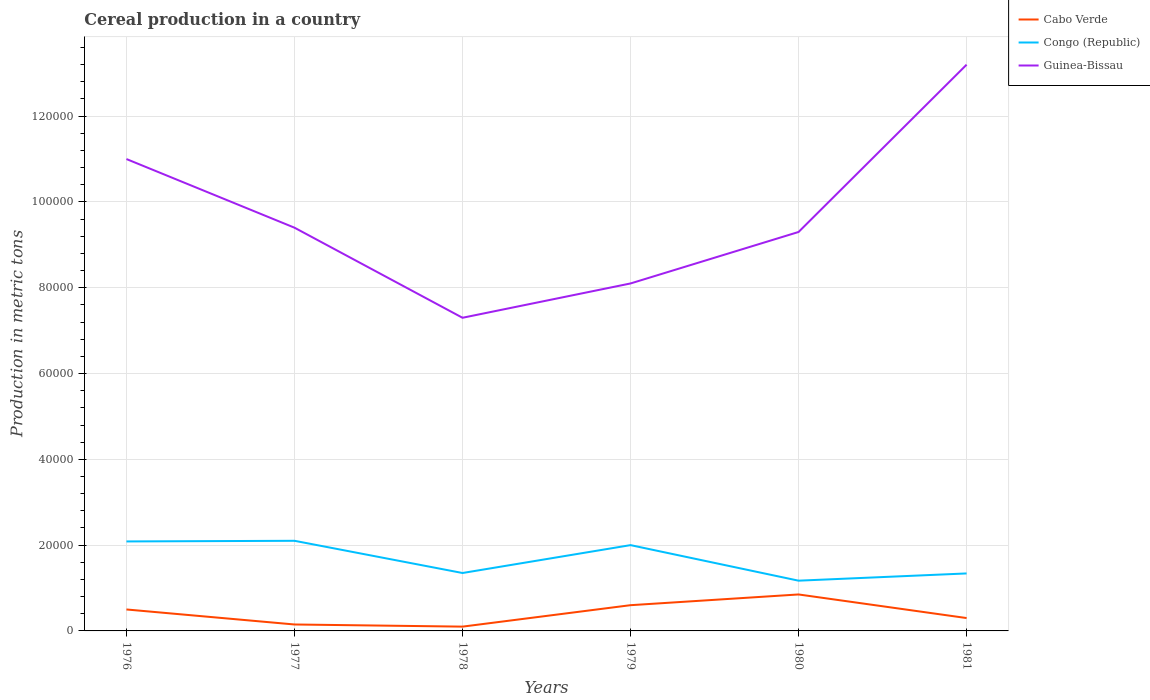How many different coloured lines are there?
Make the answer very short. 3. Across all years, what is the maximum total cereal production in Congo (Republic)?
Keep it short and to the point. 1.17e+04. In which year was the total cereal production in Cabo Verde maximum?
Your response must be concise. 1978. What is the total total cereal production in Cabo Verde in the graph?
Make the answer very short. 3000. What is the difference between the highest and the second highest total cereal production in Congo (Republic)?
Give a very brief answer. 9298. What is the difference between the highest and the lowest total cereal production in Congo (Republic)?
Provide a short and direct response. 3. How many years are there in the graph?
Make the answer very short. 6. Does the graph contain any zero values?
Provide a succinct answer. No. Does the graph contain grids?
Offer a terse response. Yes. What is the title of the graph?
Ensure brevity in your answer.  Cereal production in a country. What is the label or title of the Y-axis?
Ensure brevity in your answer.  Production in metric tons. What is the Production in metric tons in Congo (Republic) in 1976?
Ensure brevity in your answer.  2.09e+04. What is the Production in metric tons of Cabo Verde in 1977?
Your answer should be compact. 1500. What is the Production in metric tons of Congo (Republic) in 1977?
Keep it short and to the point. 2.10e+04. What is the Production in metric tons in Guinea-Bissau in 1977?
Offer a terse response. 9.40e+04. What is the Production in metric tons in Congo (Republic) in 1978?
Your answer should be very brief. 1.35e+04. What is the Production in metric tons of Guinea-Bissau in 1978?
Ensure brevity in your answer.  7.30e+04. What is the Production in metric tons of Cabo Verde in 1979?
Your answer should be compact. 6000. What is the Production in metric tons of Congo (Republic) in 1979?
Give a very brief answer. 2.00e+04. What is the Production in metric tons of Guinea-Bissau in 1979?
Give a very brief answer. 8.10e+04. What is the Production in metric tons of Cabo Verde in 1980?
Your answer should be very brief. 8500. What is the Production in metric tons of Congo (Republic) in 1980?
Make the answer very short. 1.17e+04. What is the Production in metric tons of Guinea-Bissau in 1980?
Your answer should be very brief. 9.30e+04. What is the Production in metric tons of Cabo Verde in 1981?
Your response must be concise. 3000. What is the Production in metric tons in Congo (Republic) in 1981?
Provide a succinct answer. 1.34e+04. What is the Production in metric tons in Guinea-Bissau in 1981?
Make the answer very short. 1.32e+05. Across all years, what is the maximum Production in metric tons of Cabo Verde?
Offer a very short reply. 8500. Across all years, what is the maximum Production in metric tons of Congo (Republic)?
Give a very brief answer. 2.10e+04. Across all years, what is the maximum Production in metric tons in Guinea-Bissau?
Provide a short and direct response. 1.32e+05. Across all years, what is the minimum Production in metric tons of Congo (Republic)?
Make the answer very short. 1.17e+04. Across all years, what is the minimum Production in metric tons in Guinea-Bissau?
Provide a succinct answer. 7.30e+04. What is the total Production in metric tons of Cabo Verde in the graph?
Give a very brief answer. 2.50e+04. What is the total Production in metric tons in Congo (Republic) in the graph?
Make the answer very short. 1.00e+05. What is the total Production in metric tons in Guinea-Bissau in the graph?
Make the answer very short. 5.83e+05. What is the difference between the Production in metric tons of Cabo Verde in 1976 and that in 1977?
Ensure brevity in your answer.  3500. What is the difference between the Production in metric tons in Congo (Republic) in 1976 and that in 1977?
Your answer should be compact. -151. What is the difference between the Production in metric tons in Guinea-Bissau in 1976 and that in 1977?
Your answer should be compact. 1.60e+04. What is the difference between the Production in metric tons of Cabo Verde in 1976 and that in 1978?
Your answer should be compact. 4000. What is the difference between the Production in metric tons in Congo (Republic) in 1976 and that in 1978?
Your answer should be very brief. 7360. What is the difference between the Production in metric tons in Guinea-Bissau in 1976 and that in 1978?
Ensure brevity in your answer.  3.70e+04. What is the difference between the Production in metric tons of Cabo Verde in 1976 and that in 1979?
Your answer should be very brief. -1000. What is the difference between the Production in metric tons in Congo (Republic) in 1976 and that in 1979?
Your answer should be very brief. 860. What is the difference between the Production in metric tons of Guinea-Bissau in 1976 and that in 1979?
Offer a very short reply. 2.90e+04. What is the difference between the Production in metric tons of Cabo Verde in 1976 and that in 1980?
Provide a short and direct response. -3500. What is the difference between the Production in metric tons of Congo (Republic) in 1976 and that in 1980?
Keep it short and to the point. 9147. What is the difference between the Production in metric tons of Guinea-Bissau in 1976 and that in 1980?
Ensure brevity in your answer.  1.70e+04. What is the difference between the Production in metric tons of Congo (Republic) in 1976 and that in 1981?
Your answer should be very brief. 7460. What is the difference between the Production in metric tons in Guinea-Bissau in 1976 and that in 1981?
Keep it short and to the point. -2.20e+04. What is the difference between the Production in metric tons in Cabo Verde in 1977 and that in 1978?
Provide a succinct answer. 500. What is the difference between the Production in metric tons in Congo (Republic) in 1977 and that in 1978?
Your response must be concise. 7511. What is the difference between the Production in metric tons in Guinea-Bissau in 1977 and that in 1978?
Your answer should be compact. 2.10e+04. What is the difference between the Production in metric tons in Cabo Verde in 1977 and that in 1979?
Your answer should be very brief. -4500. What is the difference between the Production in metric tons in Congo (Republic) in 1977 and that in 1979?
Offer a terse response. 1011. What is the difference between the Production in metric tons in Guinea-Bissau in 1977 and that in 1979?
Provide a succinct answer. 1.30e+04. What is the difference between the Production in metric tons of Cabo Verde in 1977 and that in 1980?
Give a very brief answer. -7000. What is the difference between the Production in metric tons of Congo (Republic) in 1977 and that in 1980?
Keep it short and to the point. 9298. What is the difference between the Production in metric tons of Cabo Verde in 1977 and that in 1981?
Your answer should be very brief. -1500. What is the difference between the Production in metric tons in Congo (Republic) in 1977 and that in 1981?
Your answer should be very brief. 7611. What is the difference between the Production in metric tons in Guinea-Bissau in 1977 and that in 1981?
Your answer should be very brief. -3.80e+04. What is the difference between the Production in metric tons of Cabo Verde in 1978 and that in 1979?
Your response must be concise. -5000. What is the difference between the Production in metric tons of Congo (Republic) in 1978 and that in 1979?
Provide a short and direct response. -6500. What is the difference between the Production in metric tons of Guinea-Bissau in 1978 and that in 1979?
Provide a short and direct response. -8000. What is the difference between the Production in metric tons in Cabo Verde in 1978 and that in 1980?
Keep it short and to the point. -7500. What is the difference between the Production in metric tons of Congo (Republic) in 1978 and that in 1980?
Ensure brevity in your answer.  1787. What is the difference between the Production in metric tons of Cabo Verde in 1978 and that in 1981?
Give a very brief answer. -2000. What is the difference between the Production in metric tons of Guinea-Bissau in 1978 and that in 1981?
Keep it short and to the point. -5.90e+04. What is the difference between the Production in metric tons in Cabo Verde in 1979 and that in 1980?
Your response must be concise. -2500. What is the difference between the Production in metric tons of Congo (Republic) in 1979 and that in 1980?
Give a very brief answer. 8287. What is the difference between the Production in metric tons of Guinea-Bissau in 1979 and that in 1980?
Your response must be concise. -1.20e+04. What is the difference between the Production in metric tons of Cabo Verde in 1979 and that in 1981?
Give a very brief answer. 3000. What is the difference between the Production in metric tons of Congo (Republic) in 1979 and that in 1981?
Give a very brief answer. 6600. What is the difference between the Production in metric tons in Guinea-Bissau in 1979 and that in 1981?
Ensure brevity in your answer.  -5.10e+04. What is the difference between the Production in metric tons of Cabo Verde in 1980 and that in 1981?
Your answer should be very brief. 5500. What is the difference between the Production in metric tons in Congo (Republic) in 1980 and that in 1981?
Provide a succinct answer. -1687. What is the difference between the Production in metric tons in Guinea-Bissau in 1980 and that in 1981?
Keep it short and to the point. -3.90e+04. What is the difference between the Production in metric tons of Cabo Verde in 1976 and the Production in metric tons of Congo (Republic) in 1977?
Your response must be concise. -1.60e+04. What is the difference between the Production in metric tons of Cabo Verde in 1976 and the Production in metric tons of Guinea-Bissau in 1977?
Keep it short and to the point. -8.90e+04. What is the difference between the Production in metric tons of Congo (Republic) in 1976 and the Production in metric tons of Guinea-Bissau in 1977?
Keep it short and to the point. -7.31e+04. What is the difference between the Production in metric tons of Cabo Verde in 1976 and the Production in metric tons of Congo (Republic) in 1978?
Offer a very short reply. -8500. What is the difference between the Production in metric tons of Cabo Verde in 1976 and the Production in metric tons of Guinea-Bissau in 1978?
Keep it short and to the point. -6.80e+04. What is the difference between the Production in metric tons of Congo (Republic) in 1976 and the Production in metric tons of Guinea-Bissau in 1978?
Ensure brevity in your answer.  -5.21e+04. What is the difference between the Production in metric tons in Cabo Verde in 1976 and the Production in metric tons in Congo (Republic) in 1979?
Provide a short and direct response. -1.50e+04. What is the difference between the Production in metric tons of Cabo Verde in 1976 and the Production in metric tons of Guinea-Bissau in 1979?
Offer a very short reply. -7.60e+04. What is the difference between the Production in metric tons in Congo (Republic) in 1976 and the Production in metric tons in Guinea-Bissau in 1979?
Ensure brevity in your answer.  -6.01e+04. What is the difference between the Production in metric tons of Cabo Verde in 1976 and the Production in metric tons of Congo (Republic) in 1980?
Your response must be concise. -6713. What is the difference between the Production in metric tons of Cabo Verde in 1976 and the Production in metric tons of Guinea-Bissau in 1980?
Give a very brief answer. -8.80e+04. What is the difference between the Production in metric tons of Congo (Republic) in 1976 and the Production in metric tons of Guinea-Bissau in 1980?
Provide a succinct answer. -7.21e+04. What is the difference between the Production in metric tons in Cabo Verde in 1976 and the Production in metric tons in Congo (Republic) in 1981?
Offer a very short reply. -8400. What is the difference between the Production in metric tons of Cabo Verde in 1976 and the Production in metric tons of Guinea-Bissau in 1981?
Offer a terse response. -1.27e+05. What is the difference between the Production in metric tons in Congo (Republic) in 1976 and the Production in metric tons in Guinea-Bissau in 1981?
Your answer should be very brief. -1.11e+05. What is the difference between the Production in metric tons in Cabo Verde in 1977 and the Production in metric tons in Congo (Republic) in 1978?
Ensure brevity in your answer.  -1.20e+04. What is the difference between the Production in metric tons in Cabo Verde in 1977 and the Production in metric tons in Guinea-Bissau in 1978?
Give a very brief answer. -7.15e+04. What is the difference between the Production in metric tons of Congo (Republic) in 1977 and the Production in metric tons of Guinea-Bissau in 1978?
Your answer should be very brief. -5.20e+04. What is the difference between the Production in metric tons in Cabo Verde in 1977 and the Production in metric tons in Congo (Republic) in 1979?
Keep it short and to the point. -1.85e+04. What is the difference between the Production in metric tons of Cabo Verde in 1977 and the Production in metric tons of Guinea-Bissau in 1979?
Your answer should be compact. -7.95e+04. What is the difference between the Production in metric tons in Congo (Republic) in 1977 and the Production in metric tons in Guinea-Bissau in 1979?
Provide a short and direct response. -6.00e+04. What is the difference between the Production in metric tons in Cabo Verde in 1977 and the Production in metric tons in Congo (Republic) in 1980?
Your answer should be very brief. -1.02e+04. What is the difference between the Production in metric tons of Cabo Verde in 1977 and the Production in metric tons of Guinea-Bissau in 1980?
Offer a very short reply. -9.15e+04. What is the difference between the Production in metric tons in Congo (Republic) in 1977 and the Production in metric tons in Guinea-Bissau in 1980?
Keep it short and to the point. -7.20e+04. What is the difference between the Production in metric tons in Cabo Verde in 1977 and the Production in metric tons in Congo (Republic) in 1981?
Your response must be concise. -1.19e+04. What is the difference between the Production in metric tons of Cabo Verde in 1977 and the Production in metric tons of Guinea-Bissau in 1981?
Provide a short and direct response. -1.30e+05. What is the difference between the Production in metric tons of Congo (Republic) in 1977 and the Production in metric tons of Guinea-Bissau in 1981?
Make the answer very short. -1.11e+05. What is the difference between the Production in metric tons of Cabo Verde in 1978 and the Production in metric tons of Congo (Republic) in 1979?
Keep it short and to the point. -1.90e+04. What is the difference between the Production in metric tons of Congo (Republic) in 1978 and the Production in metric tons of Guinea-Bissau in 1979?
Offer a terse response. -6.75e+04. What is the difference between the Production in metric tons in Cabo Verde in 1978 and the Production in metric tons in Congo (Republic) in 1980?
Offer a terse response. -1.07e+04. What is the difference between the Production in metric tons of Cabo Verde in 1978 and the Production in metric tons of Guinea-Bissau in 1980?
Give a very brief answer. -9.20e+04. What is the difference between the Production in metric tons of Congo (Republic) in 1978 and the Production in metric tons of Guinea-Bissau in 1980?
Provide a succinct answer. -7.95e+04. What is the difference between the Production in metric tons of Cabo Verde in 1978 and the Production in metric tons of Congo (Republic) in 1981?
Make the answer very short. -1.24e+04. What is the difference between the Production in metric tons of Cabo Verde in 1978 and the Production in metric tons of Guinea-Bissau in 1981?
Make the answer very short. -1.31e+05. What is the difference between the Production in metric tons of Congo (Republic) in 1978 and the Production in metric tons of Guinea-Bissau in 1981?
Offer a very short reply. -1.18e+05. What is the difference between the Production in metric tons in Cabo Verde in 1979 and the Production in metric tons in Congo (Republic) in 1980?
Make the answer very short. -5713. What is the difference between the Production in metric tons of Cabo Verde in 1979 and the Production in metric tons of Guinea-Bissau in 1980?
Your answer should be compact. -8.70e+04. What is the difference between the Production in metric tons in Congo (Republic) in 1979 and the Production in metric tons in Guinea-Bissau in 1980?
Offer a very short reply. -7.30e+04. What is the difference between the Production in metric tons in Cabo Verde in 1979 and the Production in metric tons in Congo (Republic) in 1981?
Your answer should be compact. -7400. What is the difference between the Production in metric tons of Cabo Verde in 1979 and the Production in metric tons of Guinea-Bissau in 1981?
Your response must be concise. -1.26e+05. What is the difference between the Production in metric tons of Congo (Republic) in 1979 and the Production in metric tons of Guinea-Bissau in 1981?
Ensure brevity in your answer.  -1.12e+05. What is the difference between the Production in metric tons in Cabo Verde in 1980 and the Production in metric tons in Congo (Republic) in 1981?
Your answer should be compact. -4900. What is the difference between the Production in metric tons in Cabo Verde in 1980 and the Production in metric tons in Guinea-Bissau in 1981?
Your response must be concise. -1.24e+05. What is the difference between the Production in metric tons in Congo (Republic) in 1980 and the Production in metric tons in Guinea-Bissau in 1981?
Your answer should be compact. -1.20e+05. What is the average Production in metric tons in Cabo Verde per year?
Make the answer very short. 4166.67. What is the average Production in metric tons of Congo (Republic) per year?
Offer a very short reply. 1.67e+04. What is the average Production in metric tons of Guinea-Bissau per year?
Make the answer very short. 9.72e+04. In the year 1976, what is the difference between the Production in metric tons in Cabo Verde and Production in metric tons in Congo (Republic)?
Offer a terse response. -1.59e+04. In the year 1976, what is the difference between the Production in metric tons in Cabo Verde and Production in metric tons in Guinea-Bissau?
Offer a very short reply. -1.05e+05. In the year 1976, what is the difference between the Production in metric tons in Congo (Republic) and Production in metric tons in Guinea-Bissau?
Your answer should be compact. -8.91e+04. In the year 1977, what is the difference between the Production in metric tons of Cabo Verde and Production in metric tons of Congo (Republic)?
Provide a short and direct response. -1.95e+04. In the year 1977, what is the difference between the Production in metric tons of Cabo Verde and Production in metric tons of Guinea-Bissau?
Ensure brevity in your answer.  -9.25e+04. In the year 1977, what is the difference between the Production in metric tons of Congo (Republic) and Production in metric tons of Guinea-Bissau?
Keep it short and to the point. -7.30e+04. In the year 1978, what is the difference between the Production in metric tons of Cabo Verde and Production in metric tons of Congo (Republic)?
Make the answer very short. -1.25e+04. In the year 1978, what is the difference between the Production in metric tons of Cabo Verde and Production in metric tons of Guinea-Bissau?
Make the answer very short. -7.20e+04. In the year 1978, what is the difference between the Production in metric tons of Congo (Republic) and Production in metric tons of Guinea-Bissau?
Your answer should be very brief. -5.95e+04. In the year 1979, what is the difference between the Production in metric tons of Cabo Verde and Production in metric tons of Congo (Republic)?
Give a very brief answer. -1.40e+04. In the year 1979, what is the difference between the Production in metric tons of Cabo Verde and Production in metric tons of Guinea-Bissau?
Give a very brief answer. -7.50e+04. In the year 1979, what is the difference between the Production in metric tons in Congo (Republic) and Production in metric tons in Guinea-Bissau?
Make the answer very short. -6.10e+04. In the year 1980, what is the difference between the Production in metric tons of Cabo Verde and Production in metric tons of Congo (Republic)?
Provide a short and direct response. -3213. In the year 1980, what is the difference between the Production in metric tons of Cabo Verde and Production in metric tons of Guinea-Bissau?
Your answer should be very brief. -8.45e+04. In the year 1980, what is the difference between the Production in metric tons in Congo (Republic) and Production in metric tons in Guinea-Bissau?
Give a very brief answer. -8.13e+04. In the year 1981, what is the difference between the Production in metric tons of Cabo Verde and Production in metric tons of Congo (Republic)?
Offer a very short reply. -1.04e+04. In the year 1981, what is the difference between the Production in metric tons in Cabo Verde and Production in metric tons in Guinea-Bissau?
Your answer should be compact. -1.29e+05. In the year 1981, what is the difference between the Production in metric tons in Congo (Republic) and Production in metric tons in Guinea-Bissau?
Make the answer very short. -1.19e+05. What is the ratio of the Production in metric tons in Cabo Verde in 1976 to that in 1977?
Your response must be concise. 3.33. What is the ratio of the Production in metric tons of Guinea-Bissau in 1976 to that in 1977?
Offer a very short reply. 1.17. What is the ratio of the Production in metric tons of Congo (Republic) in 1976 to that in 1978?
Provide a short and direct response. 1.55. What is the ratio of the Production in metric tons of Guinea-Bissau in 1976 to that in 1978?
Provide a succinct answer. 1.51. What is the ratio of the Production in metric tons in Congo (Republic) in 1976 to that in 1979?
Offer a very short reply. 1.04. What is the ratio of the Production in metric tons in Guinea-Bissau in 1976 to that in 1979?
Your answer should be compact. 1.36. What is the ratio of the Production in metric tons of Cabo Verde in 1976 to that in 1980?
Offer a terse response. 0.59. What is the ratio of the Production in metric tons in Congo (Republic) in 1976 to that in 1980?
Offer a terse response. 1.78. What is the ratio of the Production in metric tons in Guinea-Bissau in 1976 to that in 1980?
Make the answer very short. 1.18. What is the ratio of the Production in metric tons in Congo (Republic) in 1976 to that in 1981?
Provide a short and direct response. 1.56. What is the ratio of the Production in metric tons of Cabo Verde in 1977 to that in 1978?
Make the answer very short. 1.5. What is the ratio of the Production in metric tons of Congo (Republic) in 1977 to that in 1978?
Keep it short and to the point. 1.56. What is the ratio of the Production in metric tons of Guinea-Bissau in 1977 to that in 1978?
Your response must be concise. 1.29. What is the ratio of the Production in metric tons in Cabo Verde in 1977 to that in 1979?
Make the answer very short. 0.25. What is the ratio of the Production in metric tons of Congo (Republic) in 1977 to that in 1979?
Give a very brief answer. 1.05. What is the ratio of the Production in metric tons in Guinea-Bissau in 1977 to that in 1979?
Offer a terse response. 1.16. What is the ratio of the Production in metric tons in Cabo Verde in 1977 to that in 1980?
Provide a succinct answer. 0.18. What is the ratio of the Production in metric tons in Congo (Republic) in 1977 to that in 1980?
Provide a short and direct response. 1.79. What is the ratio of the Production in metric tons of Guinea-Bissau in 1977 to that in 1980?
Keep it short and to the point. 1.01. What is the ratio of the Production in metric tons in Cabo Verde in 1977 to that in 1981?
Offer a very short reply. 0.5. What is the ratio of the Production in metric tons of Congo (Republic) in 1977 to that in 1981?
Offer a terse response. 1.57. What is the ratio of the Production in metric tons of Guinea-Bissau in 1977 to that in 1981?
Your answer should be compact. 0.71. What is the ratio of the Production in metric tons of Cabo Verde in 1978 to that in 1979?
Give a very brief answer. 0.17. What is the ratio of the Production in metric tons of Congo (Republic) in 1978 to that in 1979?
Provide a short and direct response. 0.68. What is the ratio of the Production in metric tons in Guinea-Bissau in 1978 to that in 1979?
Your answer should be compact. 0.9. What is the ratio of the Production in metric tons in Cabo Verde in 1978 to that in 1980?
Provide a short and direct response. 0.12. What is the ratio of the Production in metric tons of Congo (Republic) in 1978 to that in 1980?
Make the answer very short. 1.15. What is the ratio of the Production in metric tons in Guinea-Bissau in 1978 to that in 1980?
Give a very brief answer. 0.78. What is the ratio of the Production in metric tons in Congo (Republic) in 1978 to that in 1981?
Your answer should be compact. 1.01. What is the ratio of the Production in metric tons in Guinea-Bissau in 1978 to that in 1981?
Keep it short and to the point. 0.55. What is the ratio of the Production in metric tons in Cabo Verde in 1979 to that in 1980?
Make the answer very short. 0.71. What is the ratio of the Production in metric tons of Congo (Republic) in 1979 to that in 1980?
Make the answer very short. 1.71. What is the ratio of the Production in metric tons of Guinea-Bissau in 1979 to that in 1980?
Your answer should be very brief. 0.87. What is the ratio of the Production in metric tons of Congo (Republic) in 1979 to that in 1981?
Offer a very short reply. 1.49. What is the ratio of the Production in metric tons of Guinea-Bissau in 1979 to that in 1981?
Your answer should be very brief. 0.61. What is the ratio of the Production in metric tons in Cabo Verde in 1980 to that in 1981?
Ensure brevity in your answer.  2.83. What is the ratio of the Production in metric tons of Congo (Republic) in 1980 to that in 1981?
Provide a succinct answer. 0.87. What is the ratio of the Production in metric tons in Guinea-Bissau in 1980 to that in 1981?
Your answer should be very brief. 0.7. What is the difference between the highest and the second highest Production in metric tons of Cabo Verde?
Offer a terse response. 2500. What is the difference between the highest and the second highest Production in metric tons of Congo (Republic)?
Your response must be concise. 151. What is the difference between the highest and the second highest Production in metric tons of Guinea-Bissau?
Your answer should be compact. 2.20e+04. What is the difference between the highest and the lowest Production in metric tons of Cabo Verde?
Keep it short and to the point. 7500. What is the difference between the highest and the lowest Production in metric tons in Congo (Republic)?
Offer a terse response. 9298. What is the difference between the highest and the lowest Production in metric tons in Guinea-Bissau?
Provide a succinct answer. 5.90e+04. 